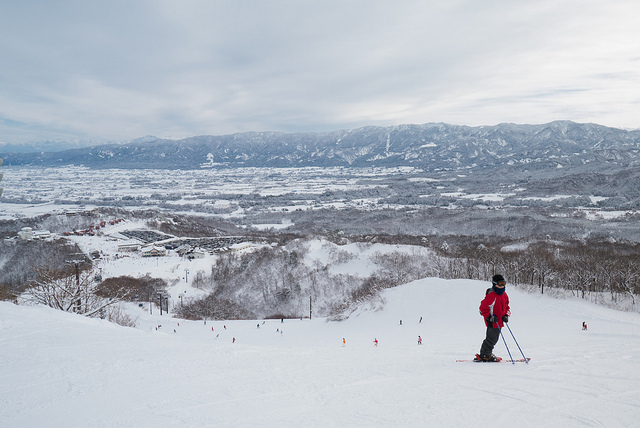<image>What mountains are these? It is ambiguous which mountains these are. They could be Alaska, Himalayas, Andes, or Rocky Mountains. What mountains are these? I don't know what mountains are these. It can be Alaska, Himalayas, Andes, Rocky Mountains, or Rockies. 